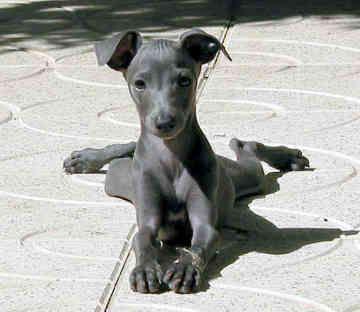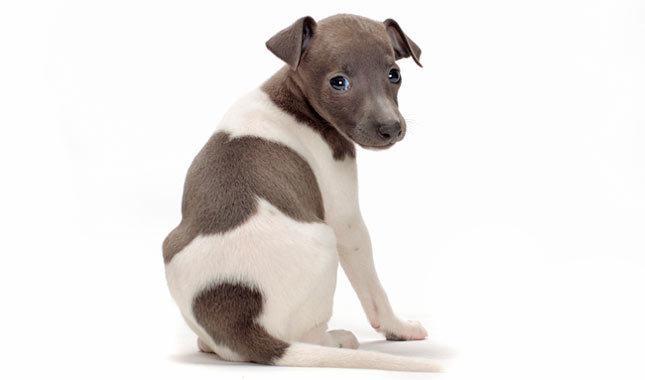The first image is the image on the left, the second image is the image on the right. Given the left and right images, does the statement "Both of the images show dogs that look like puppies." hold true? Answer yes or no. Yes. 